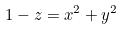<formula> <loc_0><loc_0><loc_500><loc_500>1 - z = x ^ { 2 } + y ^ { 2 }</formula> 